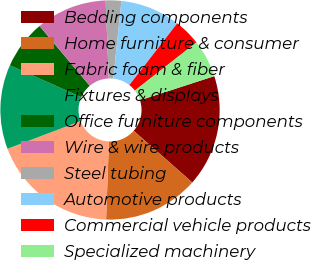<chart> <loc_0><loc_0><loc_500><loc_500><pie_chart><fcel>Bedding components<fcel>Home furniture & consumer<fcel>Fabric foam & fiber<fcel>Fixtures & displays<fcel>Office furniture components<fcel>Wire & wire products<fcel>Steel tubing<fcel>Automotive products<fcel>Commercial vehicle products<fcel>Specialized machinery<nl><fcel>16.49%<fcel>14.07%<fcel>18.67%<fcel>12.43%<fcel>7.21%<fcel>10.48%<fcel>2.29%<fcel>8.85%<fcel>3.93%<fcel>5.57%<nl></chart> 